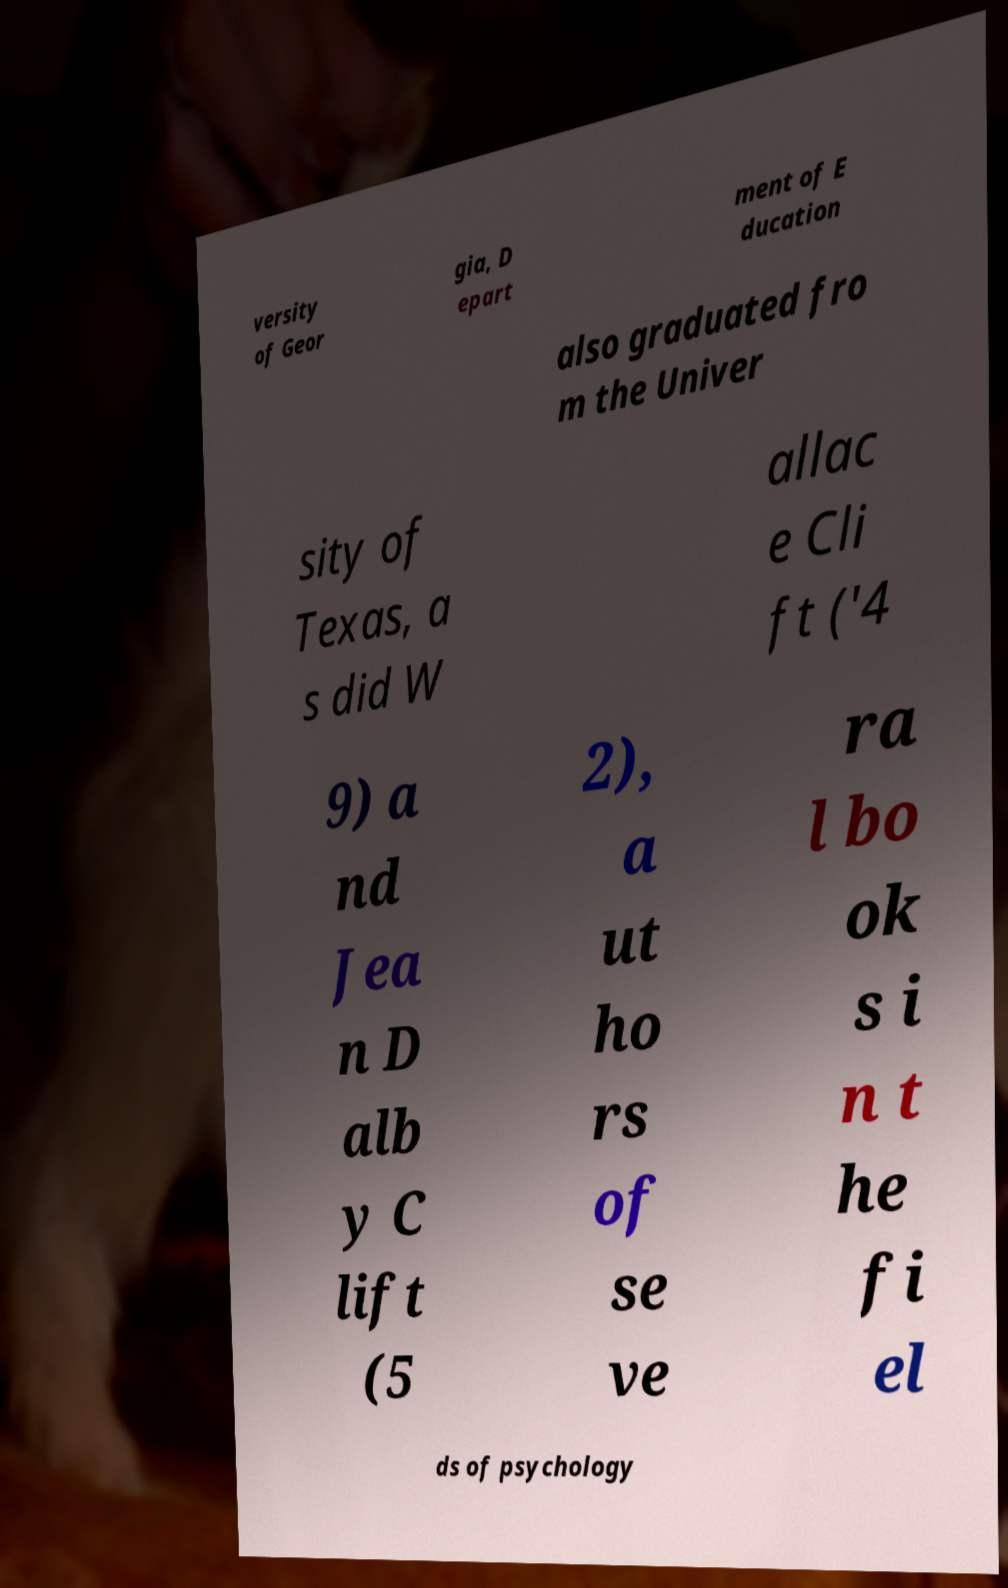Can you read and provide the text displayed in the image?This photo seems to have some interesting text. Can you extract and type it out for me? versity of Geor gia, D epart ment of E ducation also graduated fro m the Univer sity of Texas, a s did W allac e Cli ft ('4 9) a nd Jea n D alb y C lift (5 2), a ut ho rs of se ve ra l bo ok s i n t he fi el ds of psychology 